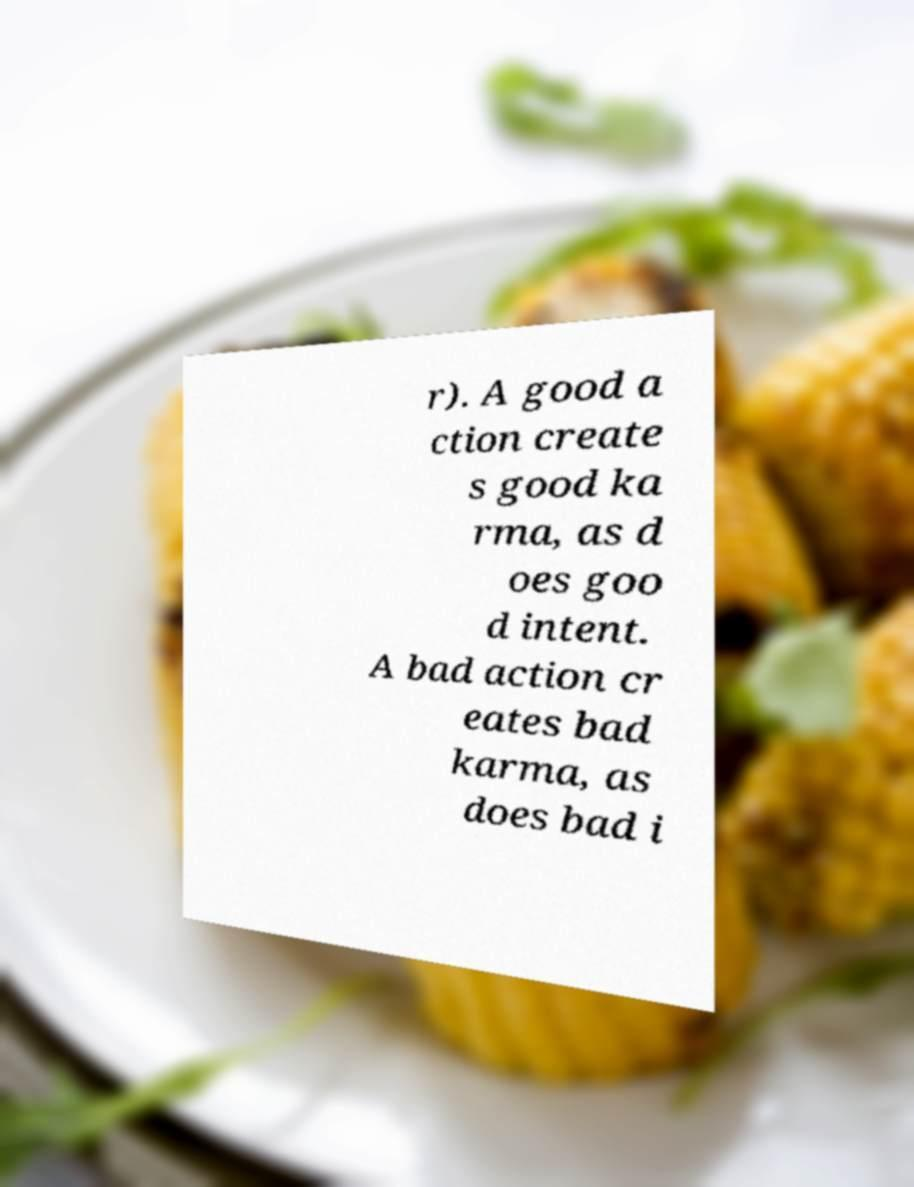There's text embedded in this image that I need extracted. Can you transcribe it verbatim? r). A good a ction create s good ka rma, as d oes goo d intent. A bad action cr eates bad karma, as does bad i 